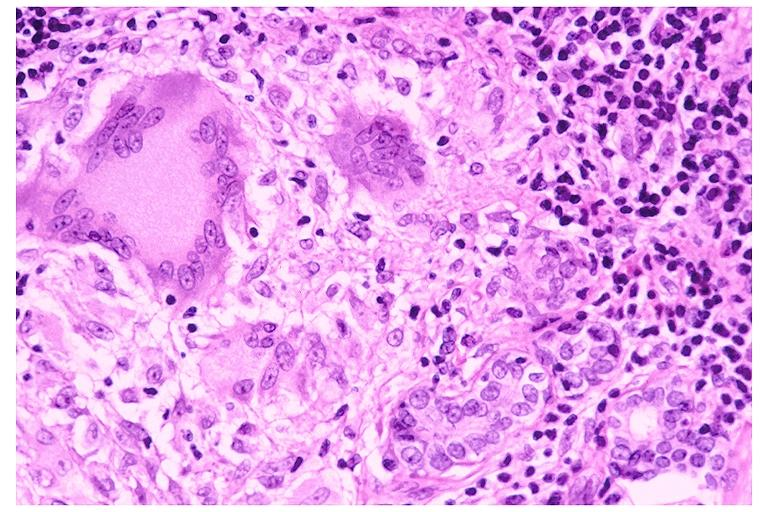what does this image show?
Answer the question using a single word or phrase. Sarcoidosis 